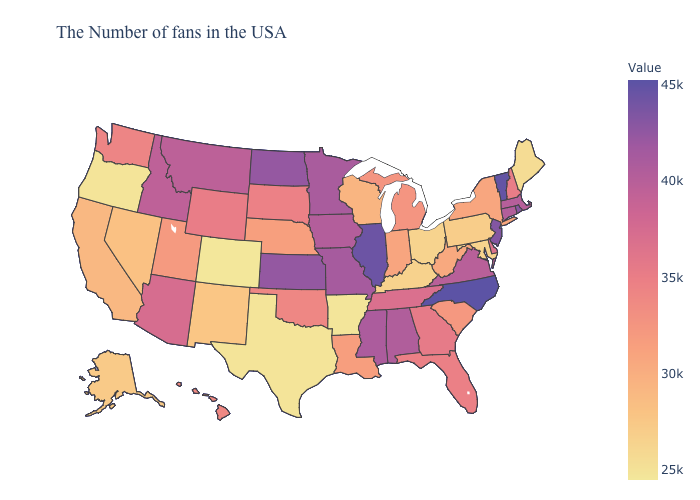Which states have the highest value in the USA?
Be succinct. North Carolina. Among the states that border Alabama , which have the highest value?
Quick response, please. Mississippi. Which states hav the highest value in the South?
Quick response, please. North Carolina. Does Arkansas have the lowest value in the South?
Concise answer only. Yes. Which states hav the highest value in the West?
Keep it brief. Montana. Which states have the highest value in the USA?
Write a very short answer. North Carolina. 